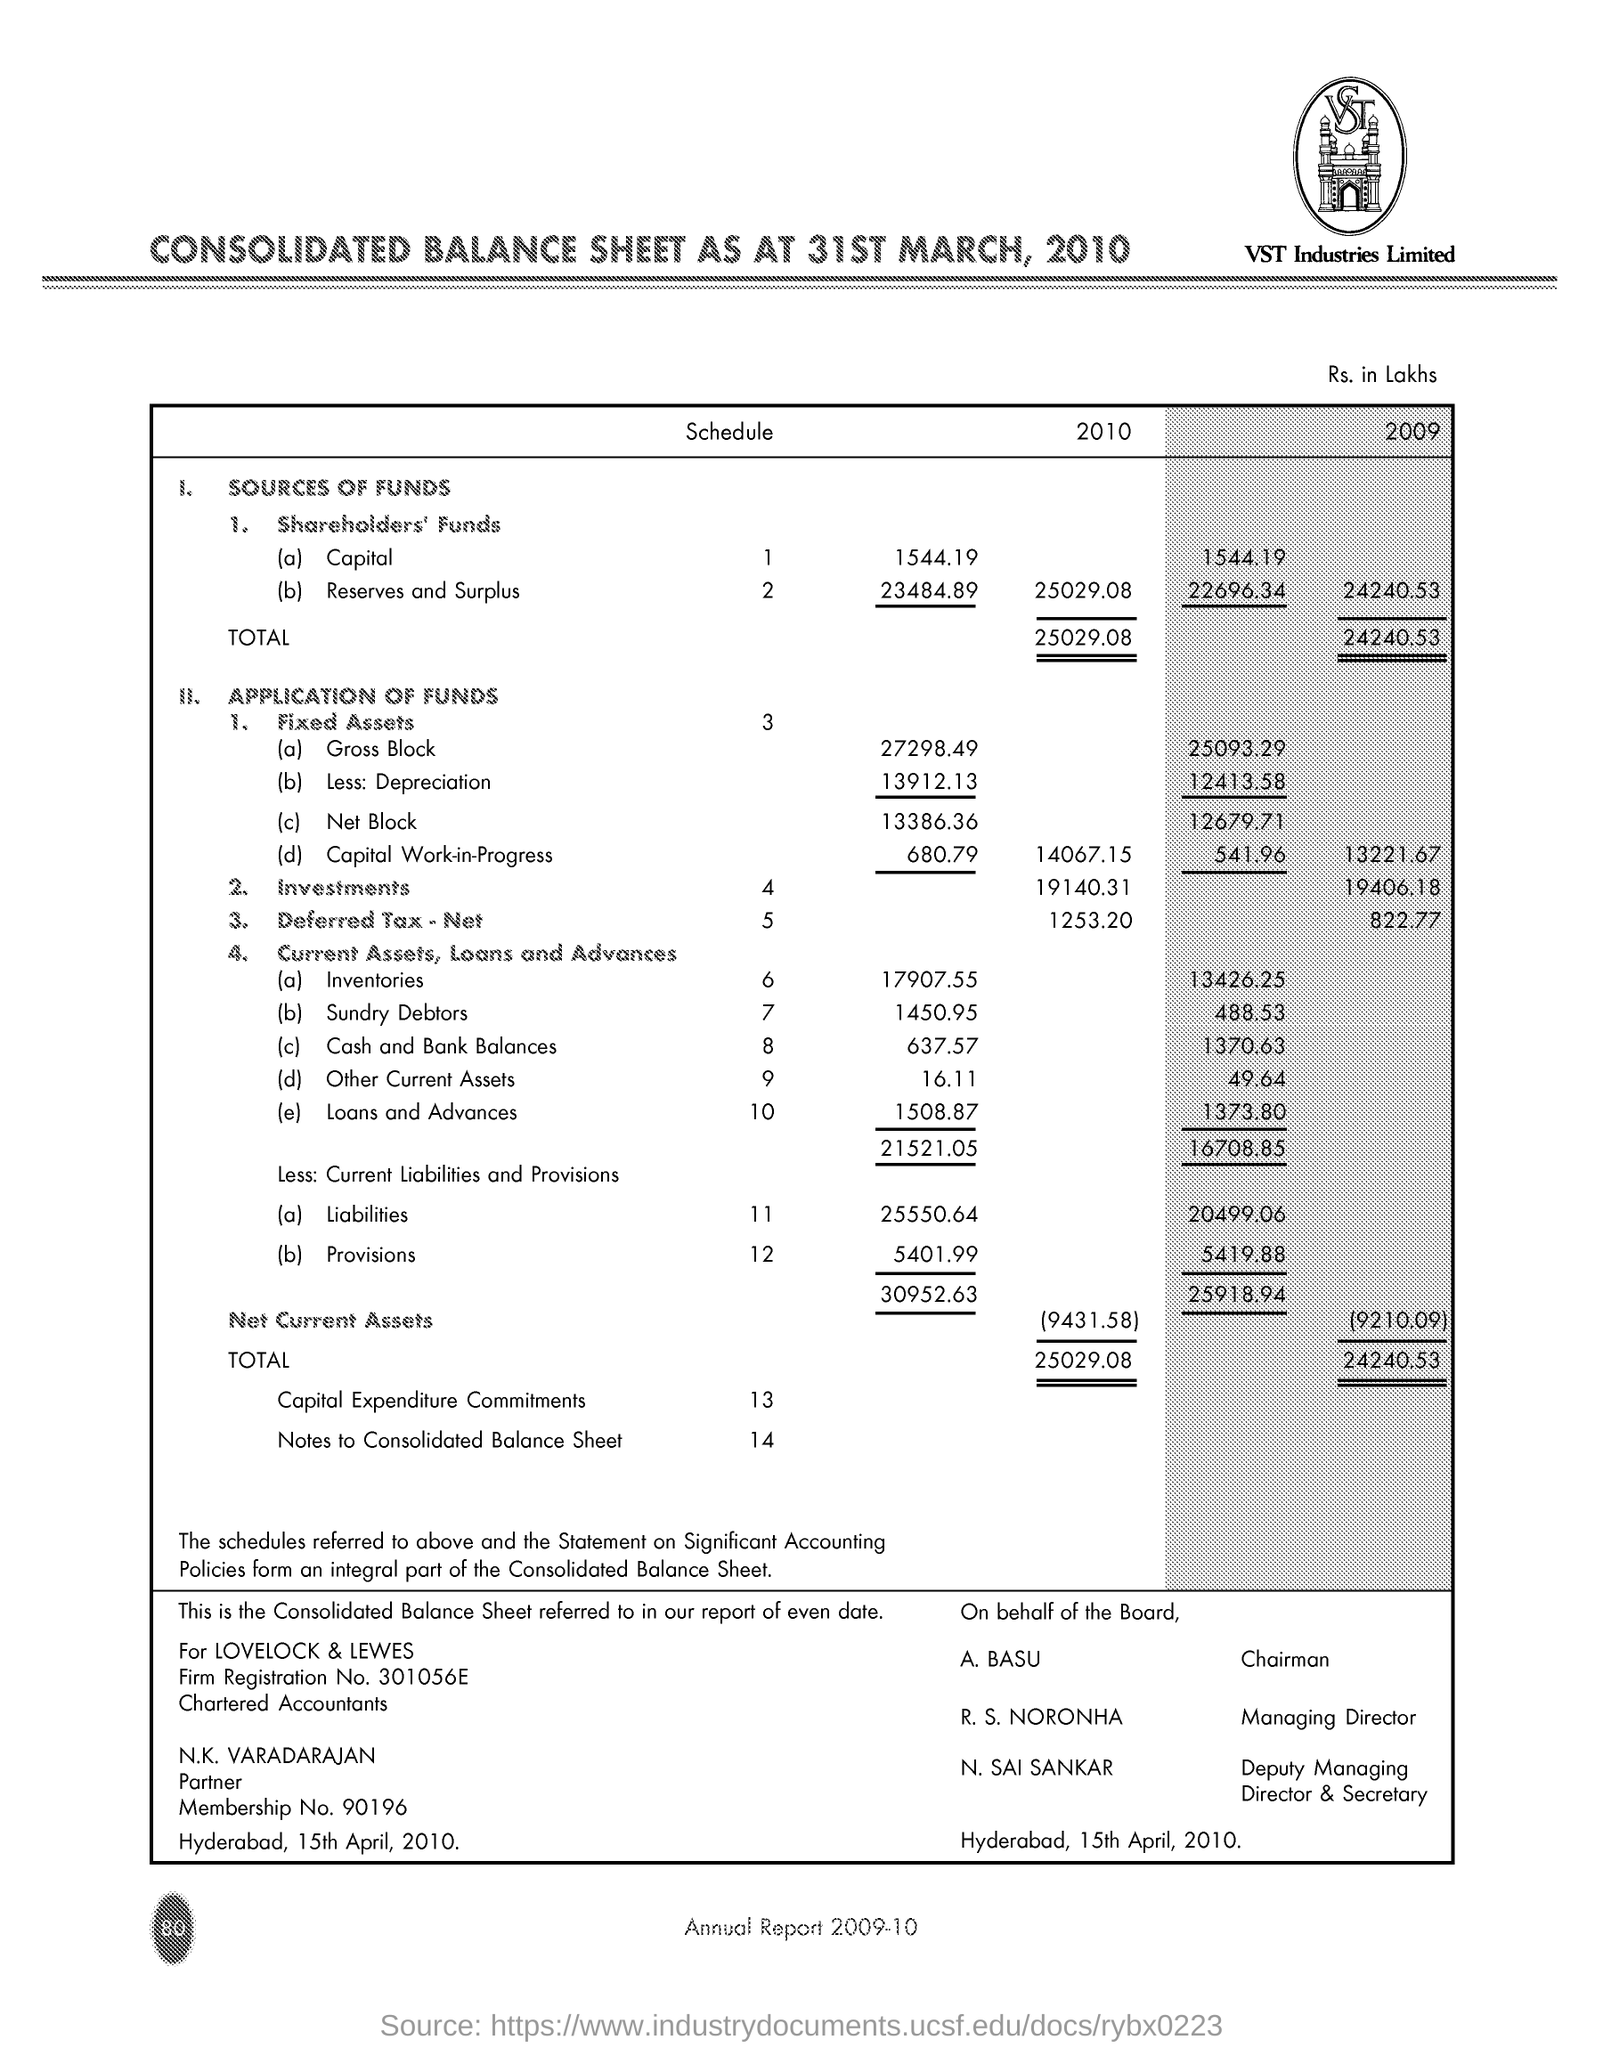Outline some significant characteristics in this image. N. SAI SANKAR is the Deputy Managing Director & Secretary. The membership number is 90196... The Chairman is A. BASU. The firm registration number is 301056E. What is the Investments Schedule Number? It is 4. 